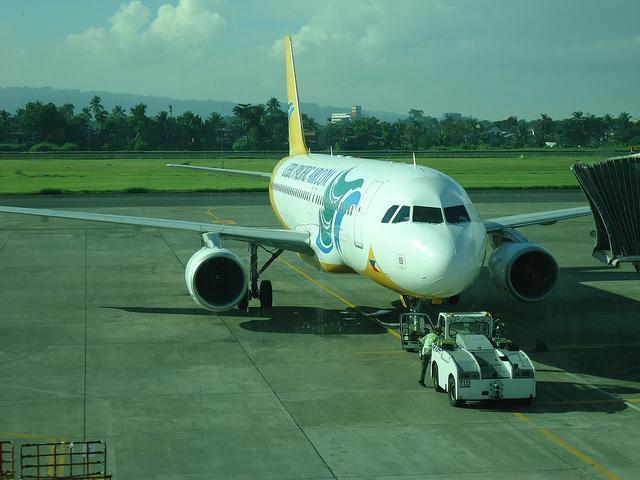How many planes are there?
Give a very brief answer. 1. 